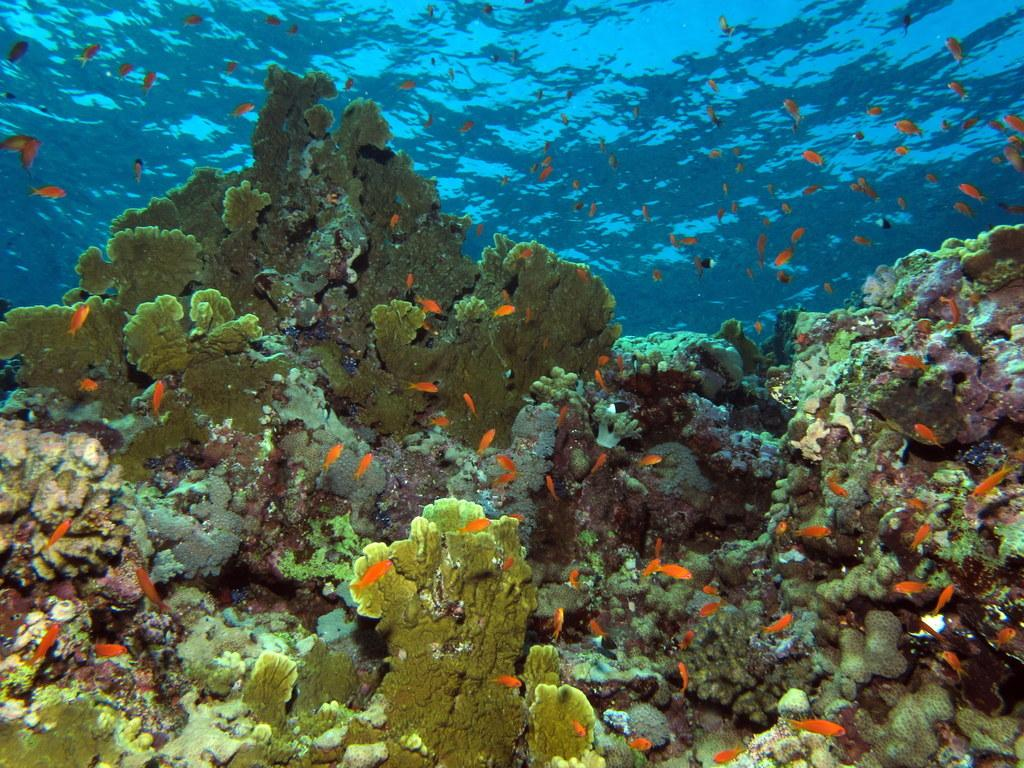What type of environment is shown in the image? The image depicts an underwater view. What types of creatures can be seen in the image? There are fish in the area of the image. What type of teeth can be seen on the hope in the image? There is no hope present in the image, and therefore no teeth can be seen on it. 